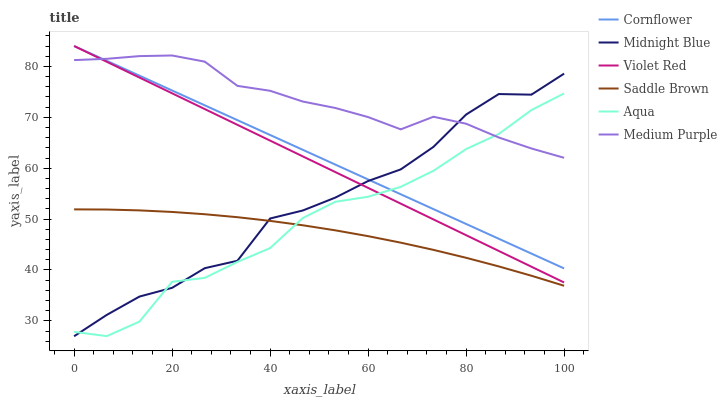Does Saddle Brown have the minimum area under the curve?
Answer yes or no. Yes. Does Medium Purple have the maximum area under the curve?
Answer yes or no. Yes. Does Violet Red have the minimum area under the curve?
Answer yes or no. No. Does Violet Red have the maximum area under the curve?
Answer yes or no. No. Is Violet Red the smoothest?
Answer yes or no. Yes. Is Midnight Blue the roughest?
Answer yes or no. Yes. Is Midnight Blue the smoothest?
Answer yes or no. No. Is Violet Red the roughest?
Answer yes or no. No. Does Midnight Blue have the lowest value?
Answer yes or no. Yes. Does Violet Red have the lowest value?
Answer yes or no. No. Does Violet Red have the highest value?
Answer yes or no. Yes. Does Midnight Blue have the highest value?
Answer yes or no. No. Is Saddle Brown less than Cornflower?
Answer yes or no. Yes. Is Cornflower greater than Saddle Brown?
Answer yes or no. Yes. Does Cornflower intersect Aqua?
Answer yes or no. Yes. Is Cornflower less than Aqua?
Answer yes or no. No. Is Cornflower greater than Aqua?
Answer yes or no. No. Does Saddle Brown intersect Cornflower?
Answer yes or no. No. 